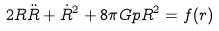Convert formula to latex. <formula><loc_0><loc_0><loc_500><loc_500>2 R \ddot { R } + \dot { R } ^ { 2 } + 8 \pi G p R ^ { 2 } = f ( r )</formula> 